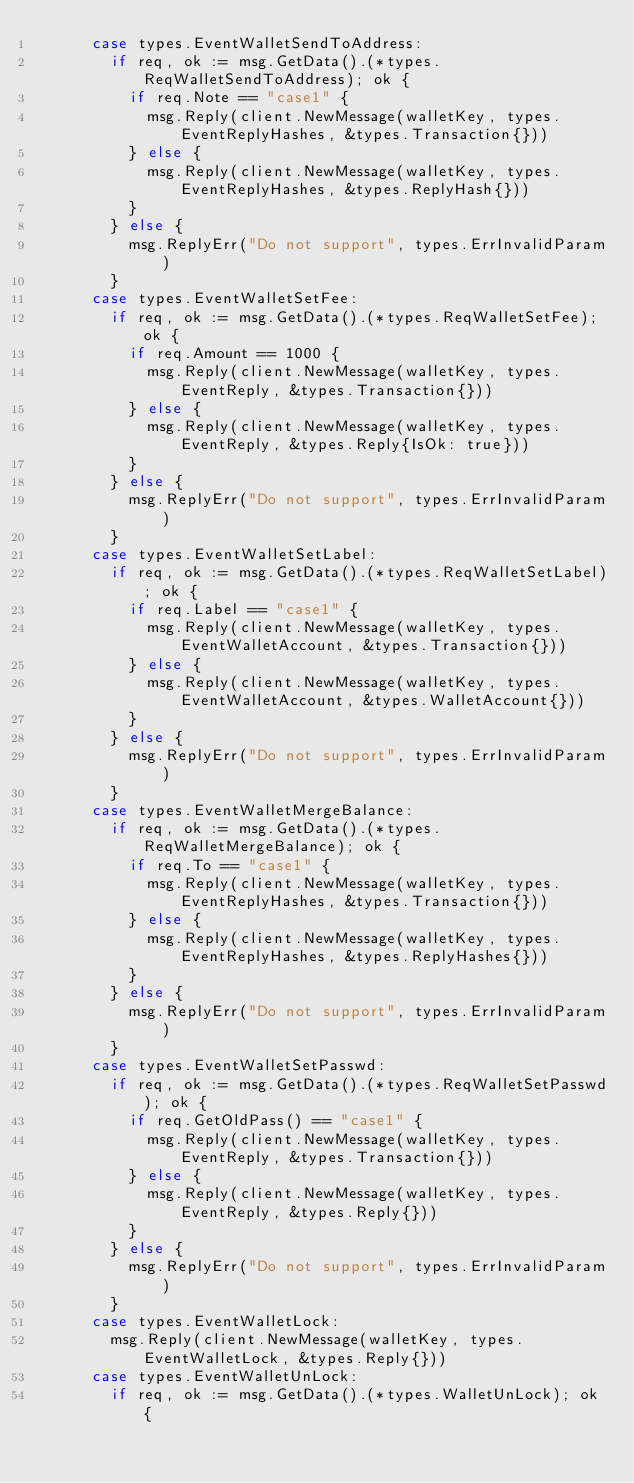<code> <loc_0><loc_0><loc_500><loc_500><_Go_>			case types.EventWalletSendToAddress:
				if req, ok := msg.GetData().(*types.ReqWalletSendToAddress); ok {
					if req.Note == "case1" {
						msg.Reply(client.NewMessage(walletKey, types.EventReplyHashes, &types.Transaction{}))
					} else {
						msg.Reply(client.NewMessage(walletKey, types.EventReplyHashes, &types.ReplyHash{}))
					}
				} else {
					msg.ReplyErr("Do not support", types.ErrInvalidParam)
				}
			case types.EventWalletSetFee:
				if req, ok := msg.GetData().(*types.ReqWalletSetFee); ok {
					if req.Amount == 1000 {
						msg.Reply(client.NewMessage(walletKey, types.EventReply, &types.Transaction{}))
					} else {
						msg.Reply(client.NewMessage(walletKey, types.EventReply, &types.Reply{IsOk: true}))
					}
				} else {
					msg.ReplyErr("Do not support", types.ErrInvalidParam)
				}
			case types.EventWalletSetLabel:
				if req, ok := msg.GetData().(*types.ReqWalletSetLabel); ok {
					if req.Label == "case1" {
						msg.Reply(client.NewMessage(walletKey, types.EventWalletAccount, &types.Transaction{}))
					} else {
						msg.Reply(client.NewMessage(walletKey, types.EventWalletAccount, &types.WalletAccount{}))
					}
				} else {
					msg.ReplyErr("Do not support", types.ErrInvalidParam)
				}
			case types.EventWalletMergeBalance:
				if req, ok := msg.GetData().(*types.ReqWalletMergeBalance); ok {
					if req.To == "case1" {
						msg.Reply(client.NewMessage(walletKey, types.EventReplyHashes, &types.Transaction{}))
					} else {
						msg.Reply(client.NewMessage(walletKey, types.EventReplyHashes, &types.ReplyHashes{}))
					}
				} else {
					msg.ReplyErr("Do not support", types.ErrInvalidParam)
				}
			case types.EventWalletSetPasswd:
				if req, ok := msg.GetData().(*types.ReqWalletSetPasswd); ok {
					if req.GetOldPass() == "case1" {
						msg.Reply(client.NewMessage(walletKey, types.EventReply, &types.Transaction{}))
					} else {
						msg.Reply(client.NewMessage(walletKey, types.EventReply, &types.Reply{}))
					}
				} else {
					msg.ReplyErr("Do not support", types.ErrInvalidParam)
				}
			case types.EventWalletLock:
				msg.Reply(client.NewMessage(walletKey, types.EventWalletLock, &types.Reply{}))
			case types.EventWalletUnLock:
				if req, ok := msg.GetData().(*types.WalletUnLock); ok {</code> 